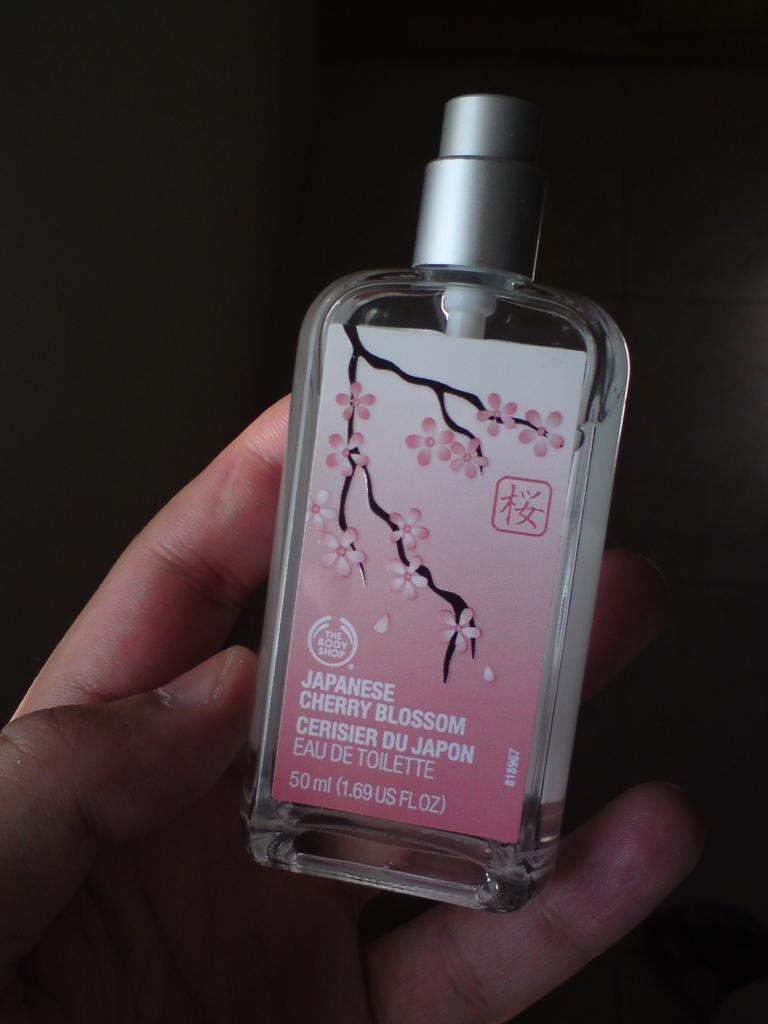<image>
Render a clear and concise summary of the photo. A spray bottle of Japanese cherry blossom perfume. 